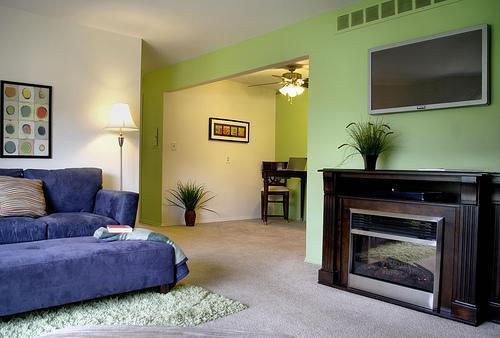How many fireplaces are there?
Give a very brief answer. 1. How many lights are visible?
Give a very brief answer. 2. 